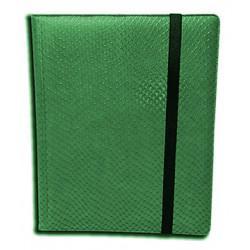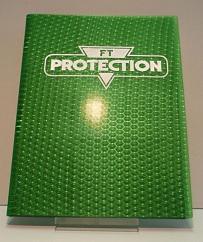The first image is the image on the left, the second image is the image on the right. Analyze the images presented: Is the assertion "The right image shows two binders." valid? Answer yes or no. No. 